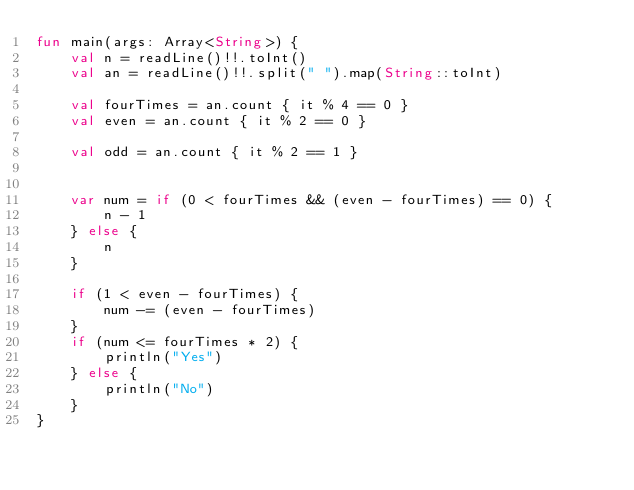Convert code to text. <code><loc_0><loc_0><loc_500><loc_500><_Kotlin_>fun main(args: Array<String>) {
    val n = readLine()!!.toInt()
    val an = readLine()!!.split(" ").map(String::toInt)

    val fourTimes = an.count { it % 4 == 0 }
    val even = an.count { it % 2 == 0 }

    val odd = an.count { it % 2 == 1 }


    var num = if (0 < fourTimes && (even - fourTimes) == 0) {
        n - 1
    } else {
        n
    }

    if (1 < even - fourTimes) {
        num -= (even - fourTimes)
    }
    if (num <= fourTimes * 2) {
        println("Yes")
    } else {
        println("No")
    }
}


</code> 